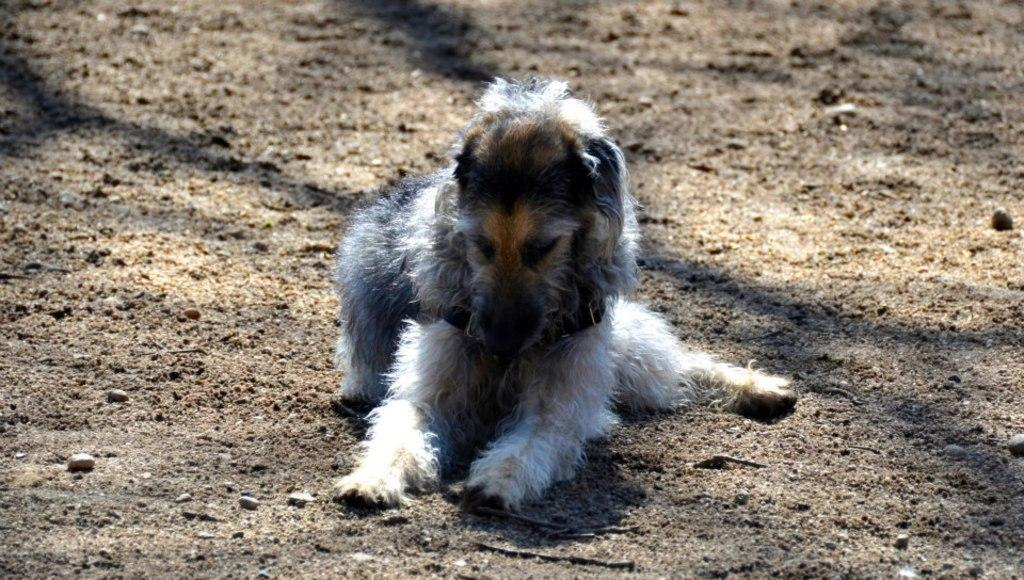What animal can be seen in the image? There is a dog in the image. What is the dog doing in the image? The dog is sitting on the ground. Can you see any visible veins on the dog's legs in the image? There is no indication of visible veins on the dog's legs in the image. Is the dog located near a part of the sea in the image? There is no sea or any body of water present in the image; it only features a dog sitting on the ground. 